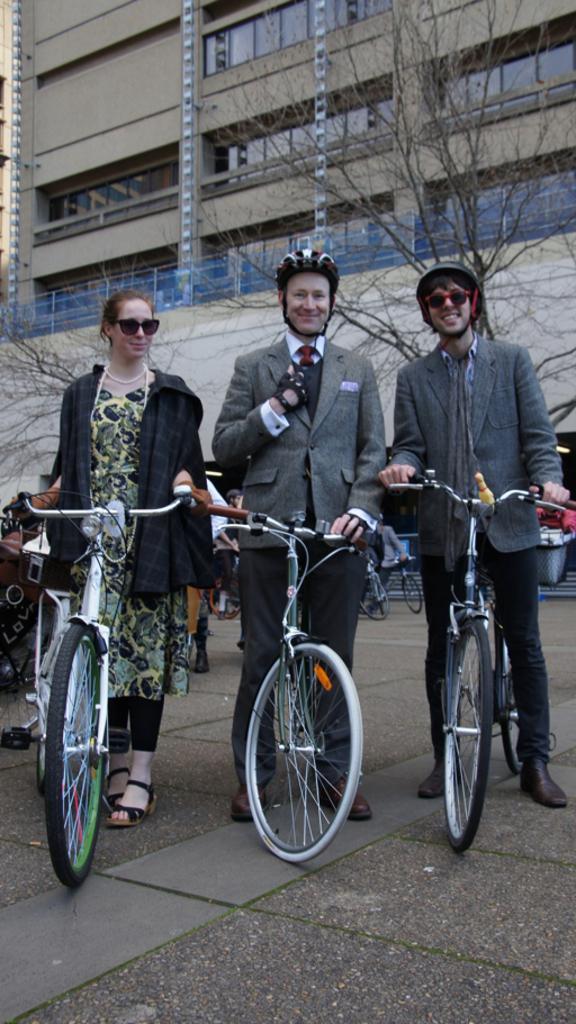Could you give a brief overview of what you see in this image? This picture describes about group of people,in the middle of the image three people are standing with bicycles, in the background we can see building and couple of trees. 